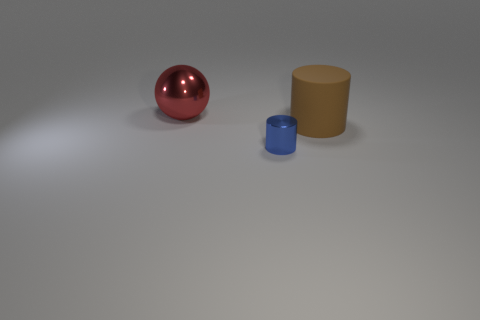Are there any other things that are the same material as the brown thing?
Make the answer very short. No. Are there any brown things on the right side of the big red shiny sphere?
Provide a short and direct response. Yes. What is the color of the rubber cylinder?
Give a very brief answer. Brown. There is a small shiny cylinder; does it have the same color as the object to the right of the tiny blue metallic object?
Offer a very short reply. No. Is there a brown object of the same size as the sphere?
Your answer should be compact. Yes. There is a thing to the left of the tiny metallic object; what material is it?
Give a very brief answer. Metal. Are there an equal number of blue shiny cylinders behind the big cylinder and big rubber cylinders that are to the right of the red thing?
Your answer should be compact. No. Is the size of the metallic object on the left side of the tiny metallic cylinder the same as the cylinder right of the small object?
Provide a succinct answer. Yes. Is the number of tiny blue metallic cylinders right of the metallic sphere greater than the number of large blue cylinders?
Make the answer very short. Yes. Does the large red metal thing have the same shape as the blue thing?
Offer a very short reply. No. 